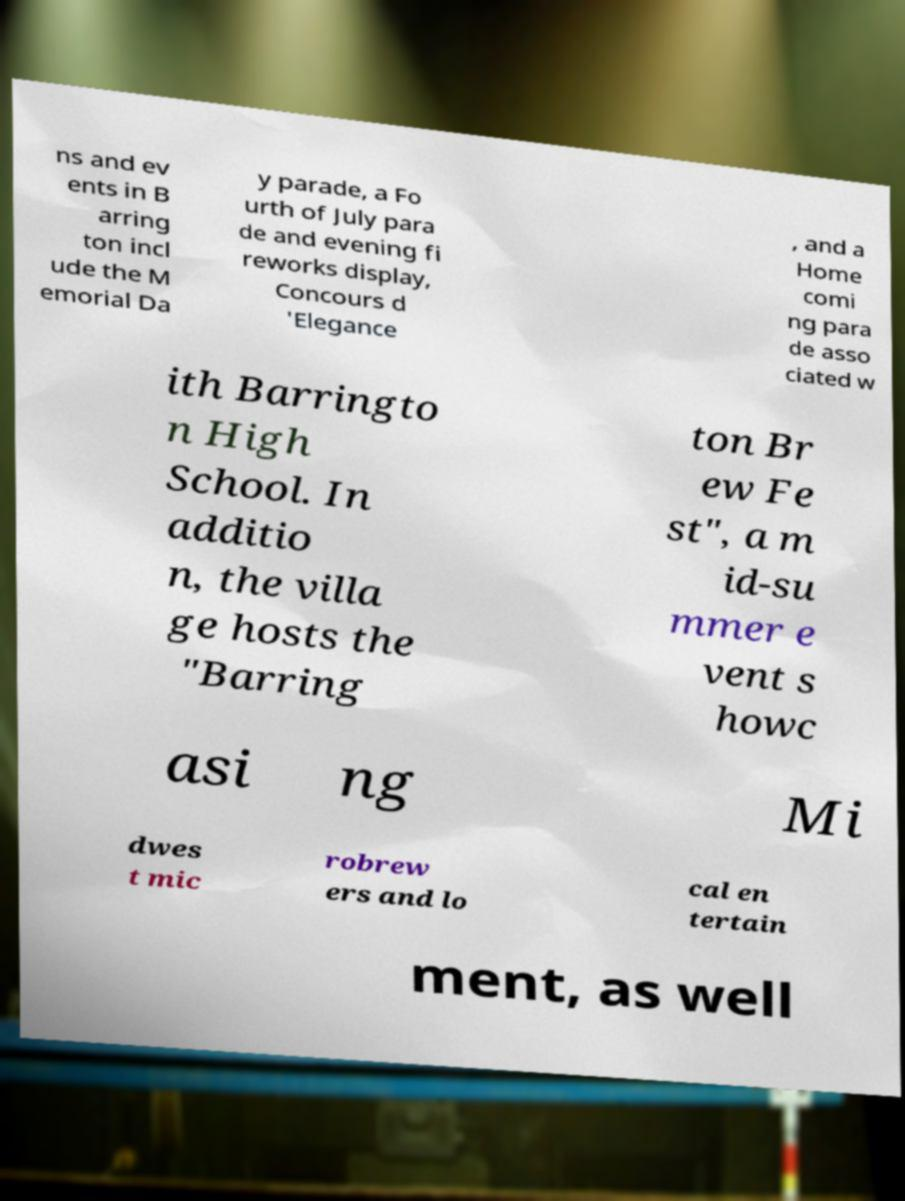Could you assist in decoding the text presented in this image and type it out clearly? ns and ev ents in B arring ton incl ude the M emorial Da y parade, a Fo urth of July para de and evening fi reworks display, Concours d 'Elegance , and a Home comi ng para de asso ciated w ith Barringto n High School. In additio n, the villa ge hosts the "Barring ton Br ew Fe st", a m id-su mmer e vent s howc asi ng Mi dwes t mic robrew ers and lo cal en tertain ment, as well 